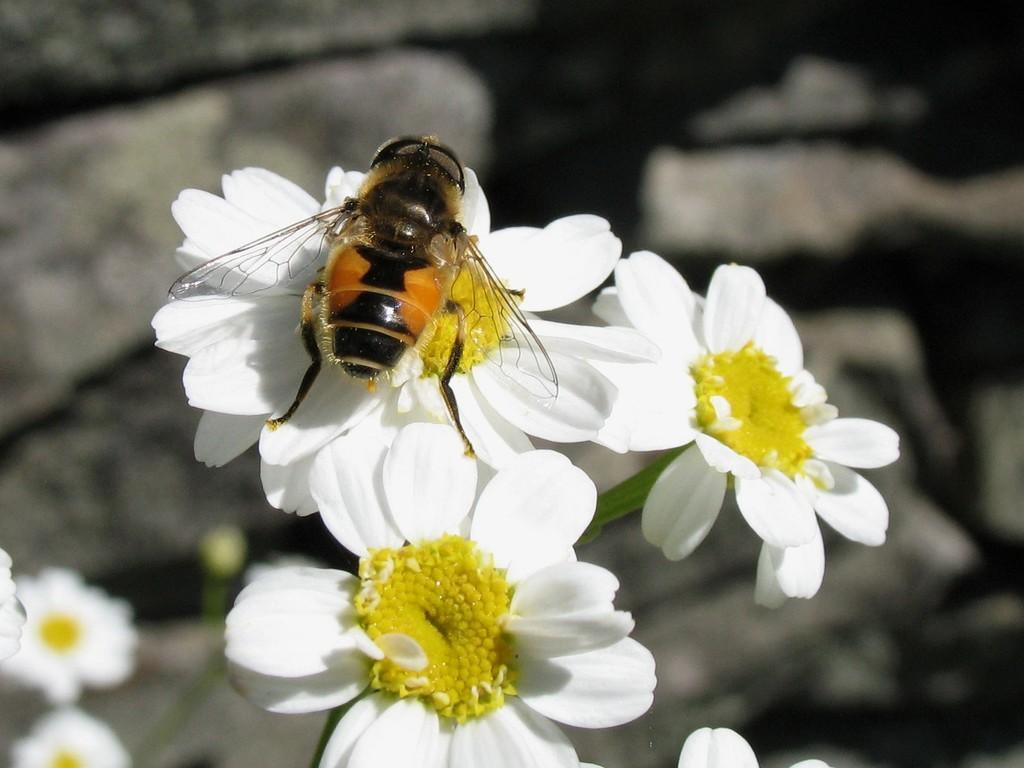In one or two sentences, can you explain what this image depicts? In this image there are white colored flowers, there is an insect on the flower, the background of the image is blurred. 